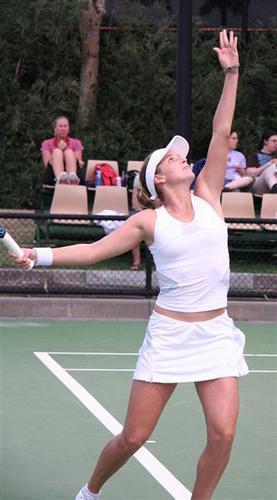How many orange boats are there?
Give a very brief answer. 0. 